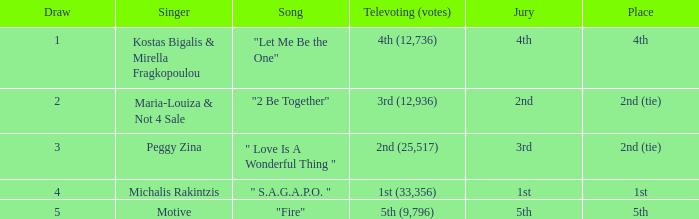Kostas Bigalis & Mirella Fragkopoulou the singer had what has the jury? 4th. Can you give me this table as a dict? {'header': ['Draw', 'Singer', 'Song', 'Televoting (votes)', 'Jury', 'Place'], 'rows': [['1', 'Kostas Bigalis & Mirella Fragkopoulou', '"Let Me Be the One"', '4th (12,736)', '4th', '4th'], ['2', 'Maria-Louiza & Not 4 Sale', '"2 Be Together"', '3rd (12,936)', '2nd', '2nd (tie)'], ['3', 'Peggy Zina', '" Love Is A Wonderful Thing "', '2nd (25,517)', '3rd', '2nd (tie)'], ['4', 'Michalis Rakintzis', '" S.A.G.A.P.O. "', '1st (33,356)', '1st', '1st'], ['5', 'Motive', '"Fire"', '5th (9,796)', '5th', '5th']]} 